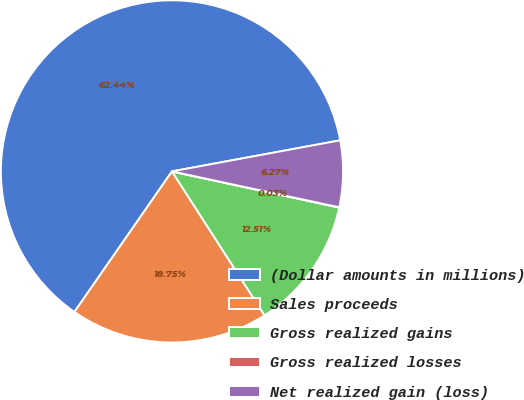Convert chart. <chart><loc_0><loc_0><loc_500><loc_500><pie_chart><fcel>(Dollar amounts in millions)<fcel>Sales proceeds<fcel>Gross realized gains<fcel>Gross realized losses<fcel>Net realized gain (loss)<nl><fcel>62.43%<fcel>18.75%<fcel>12.51%<fcel>0.03%<fcel>6.27%<nl></chart> 